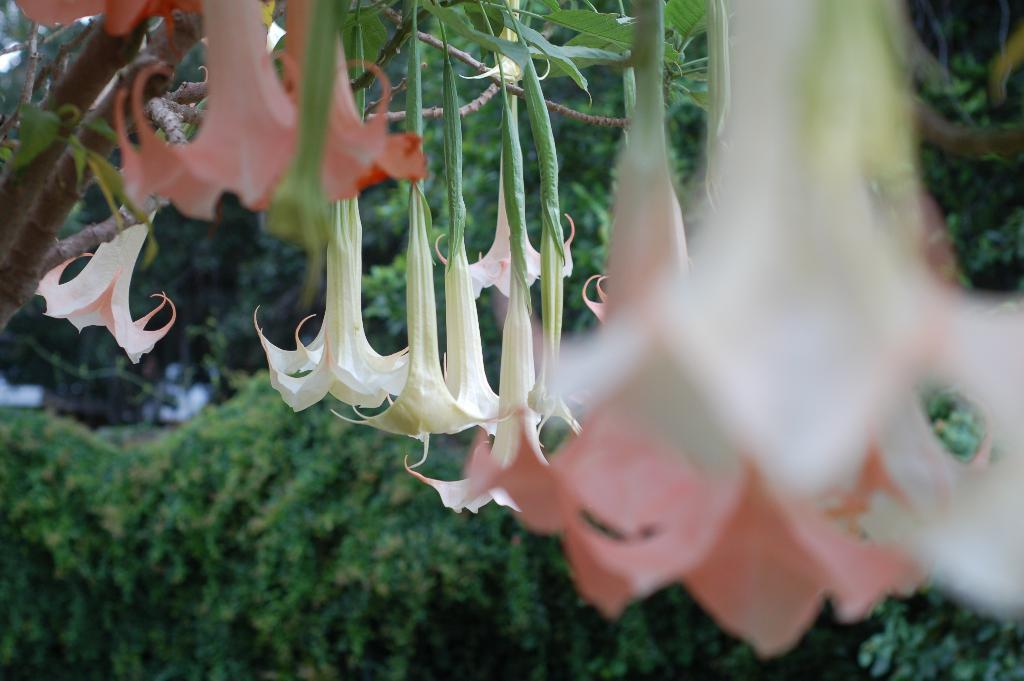What is located in the foreground of the image? There are flowers in the foreground of the image. How are the flowers positioned in relation to the tree? The flowers are hanging upside down from a tree. What can be seen in the background of the image? There is greenery visible in the background of the image. Can you describe the motion of the giraffe in the image? There is no giraffe present in the image, so its motion cannot be described. 